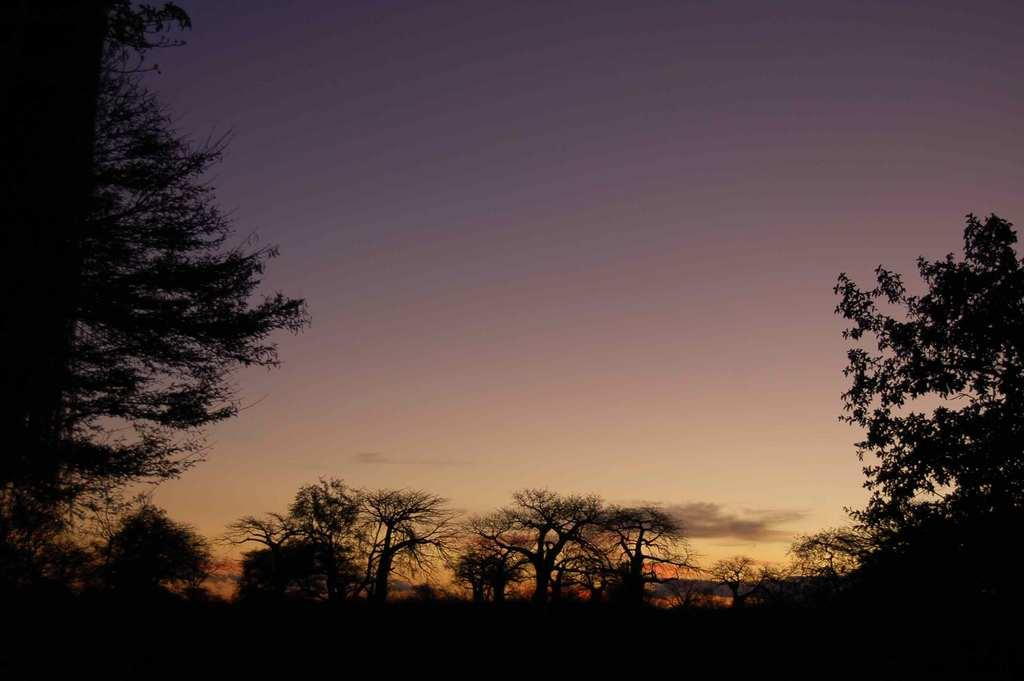What type of vegetation can be seen in the image? There are trees in the image. What colors are present in the sky in the background? The sky in the background has purple, white, and orange colors. How many ducks are sitting on the corn in the image? There are no ducks or corn present in the image. Is there a fire visible in the image? There is no fire present in the image. 